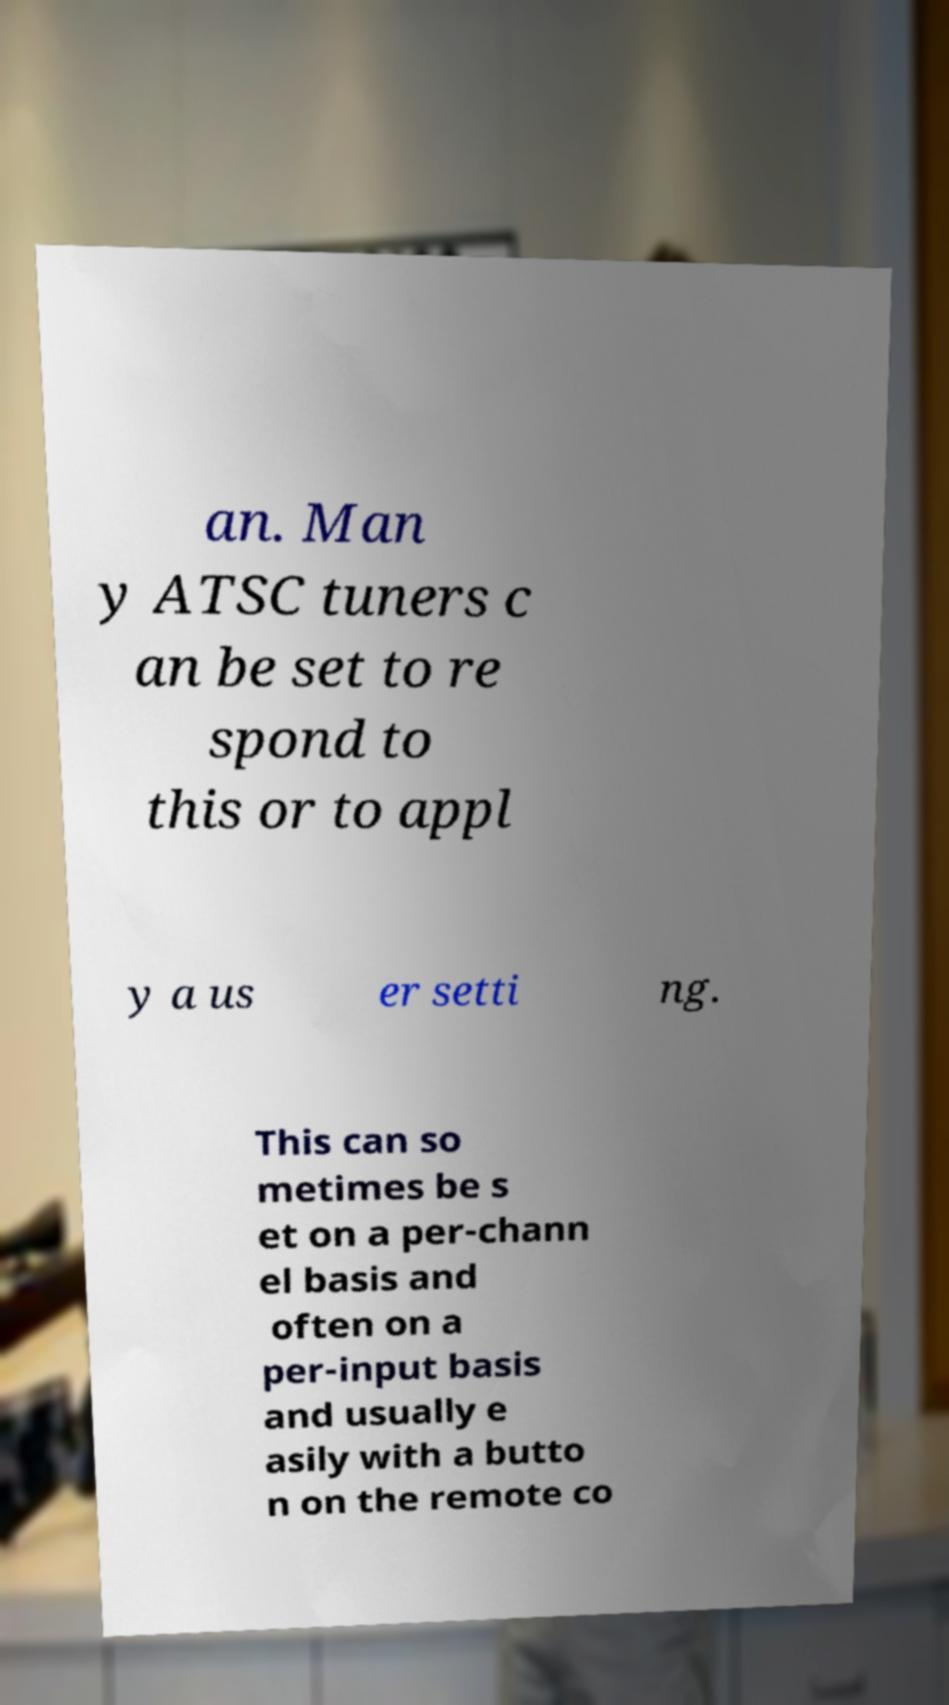For documentation purposes, I need the text within this image transcribed. Could you provide that? an. Man y ATSC tuners c an be set to re spond to this or to appl y a us er setti ng. This can so metimes be s et on a per-chann el basis and often on a per-input basis and usually e asily with a butto n on the remote co 